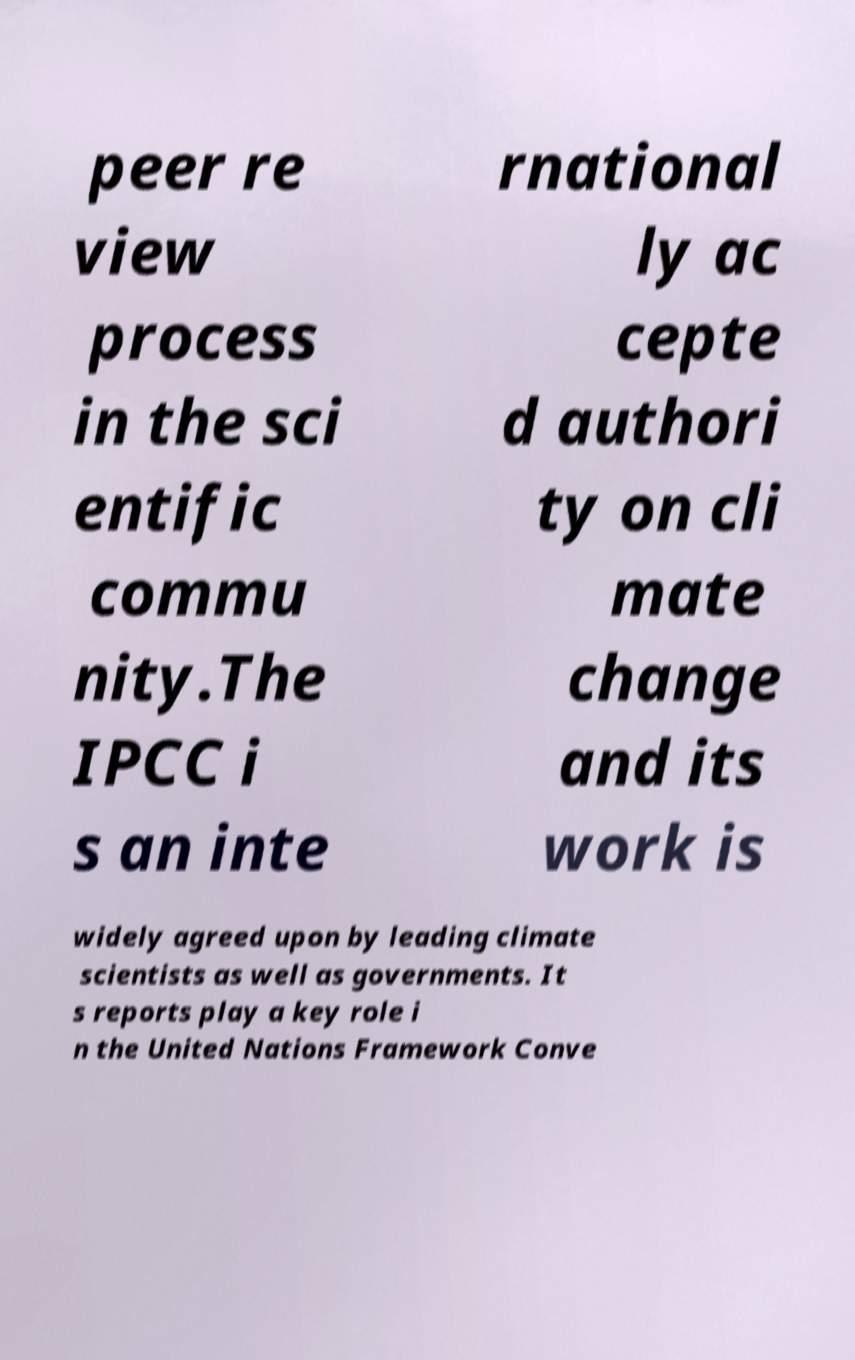What messages or text are displayed in this image? I need them in a readable, typed format. peer re view process in the sci entific commu nity.The IPCC i s an inte rnational ly ac cepte d authori ty on cli mate change and its work is widely agreed upon by leading climate scientists as well as governments. It s reports play a key role i n the United Nations Framework Conve 